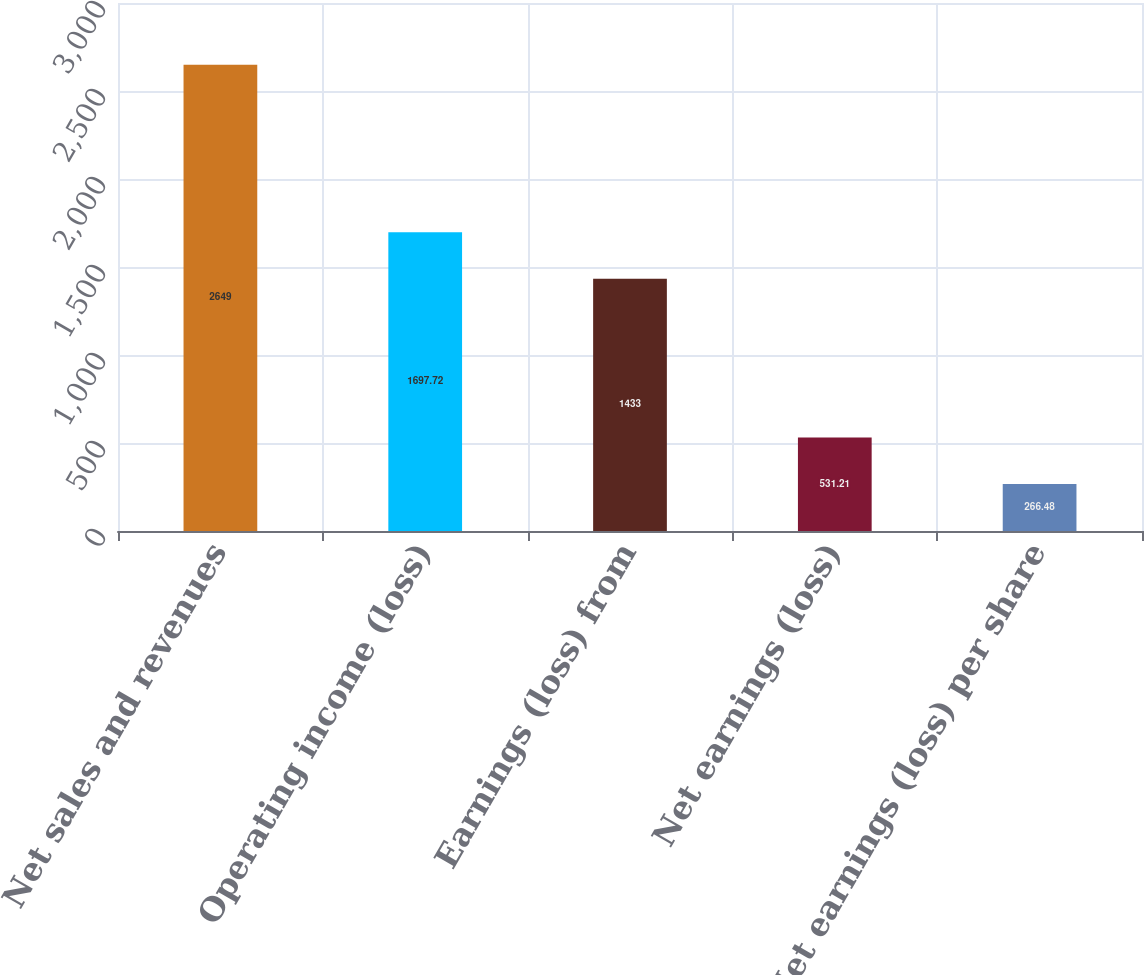Convert chart to OTSL. <chart><loc_0><loc_0><loc_500><loc_500><bar_chart><fcel>Net sales and revenues<fcel>Operating income (loss)<fcel>Earnings (loss) from<fcel>Net earnings (loss)<fcel>Net earnings (loss) per share<nl><fcel>2649<fcel>1697.72<fcel>1433<fcel>531.21<fcel>266.48<nl></chart> 